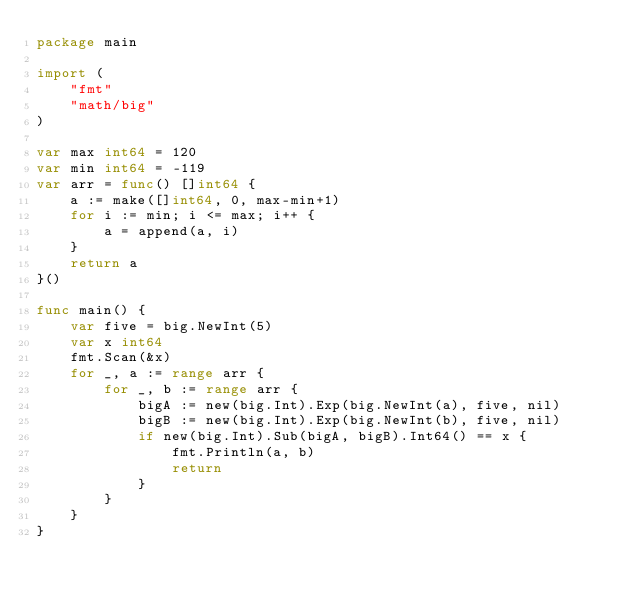<code> <loc_0><loc_0><loc_500><loc_500><_Go_>package main

import (
	"fmt"
	"math/big"
)

var max int64 = 120
var min int64 = -119
var arr = func() []int64 {
	a := make([]int64, 0, max-min+1)
	for i := min; i <= max; i++ {
		a = append(a, i)
	}
	return a
}()

func main() {
	var five = big.NewInt(5)
	var x int64
	fmt.Scan(&x)
	for _, a := range arr {
		for _, b := range arr {
			bigA := new(big.Int).Exp(big.NewInt(a), five, nil)
			bigB := new(big.Int).Exp(big.NewInt(b), five, nil)
			if new(big.Int).Sub(bigA, bigB).Int64() == x {
				fmt.Println(a, b)
				return
			}
		}
	}
}
</code> 